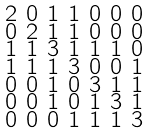Convert formula to latex. <formula><loc_0><loc_0><loc_500><loc_500>\begin{smallmatrix} 2 & 0 & 1 & 1 & 0 & 0 & 0 \\ 0 & 2 & 1 & 1 & 0 & 0 & 0 \\ 1 & 1 & 3 & 1 & 1 & 1 & 0 \\ 1 & 1 & 1 & 3 & 0 & 0 & 1 \\ 0 & 0 & 1 & 0 & 3 & 1 & 1 \\ 0 & 0 & 1 & 0 & 1 & 3 & 1 \\ 0 & 0 & 0 & 1 & 1 & 1 & 3 \end{smallmatrix}</formula> 